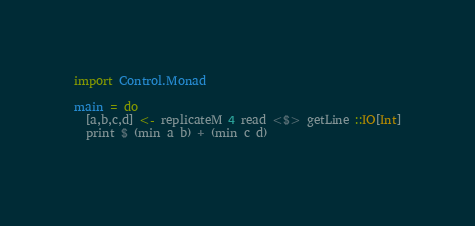Convert code to text. <code><loc_0><loc_0><loc_500><loc_500><_Haskell_>import Control.Monad

main = do
  [a,b,c,d] <- replicateM 4 read <$> getLine ::IO[Int]
  print $ (min a b) + (min c d)
  
</code> 